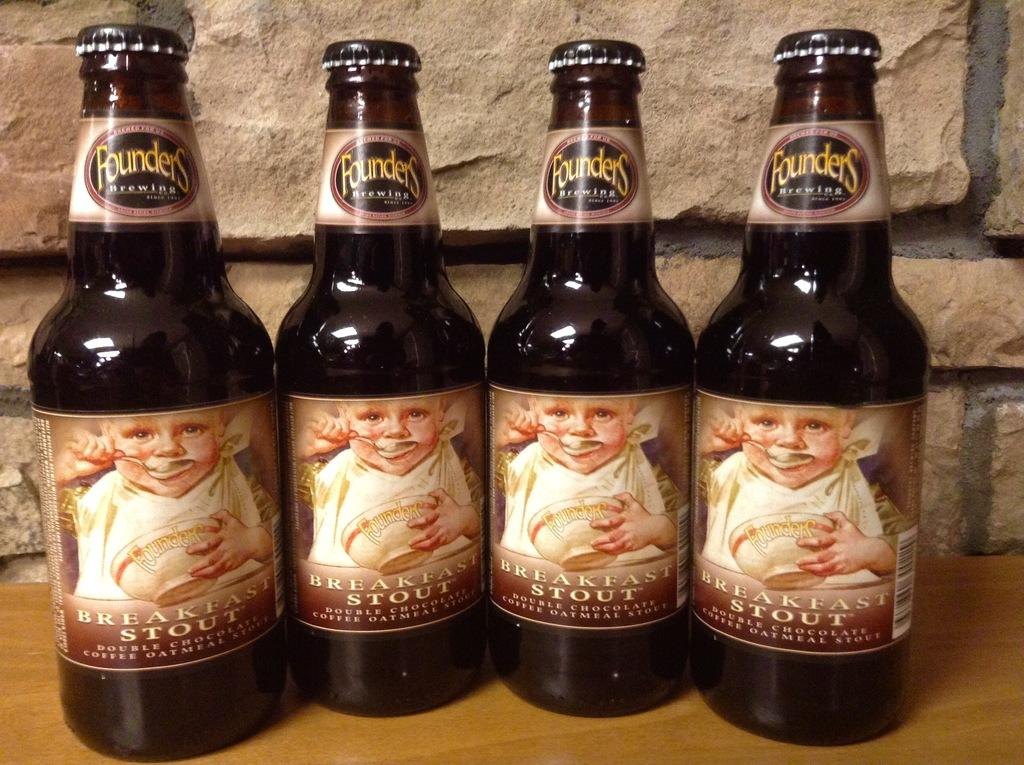<image>
Describe the image concisely. Four bottles of Founders breakfast stout sit next to each other. 